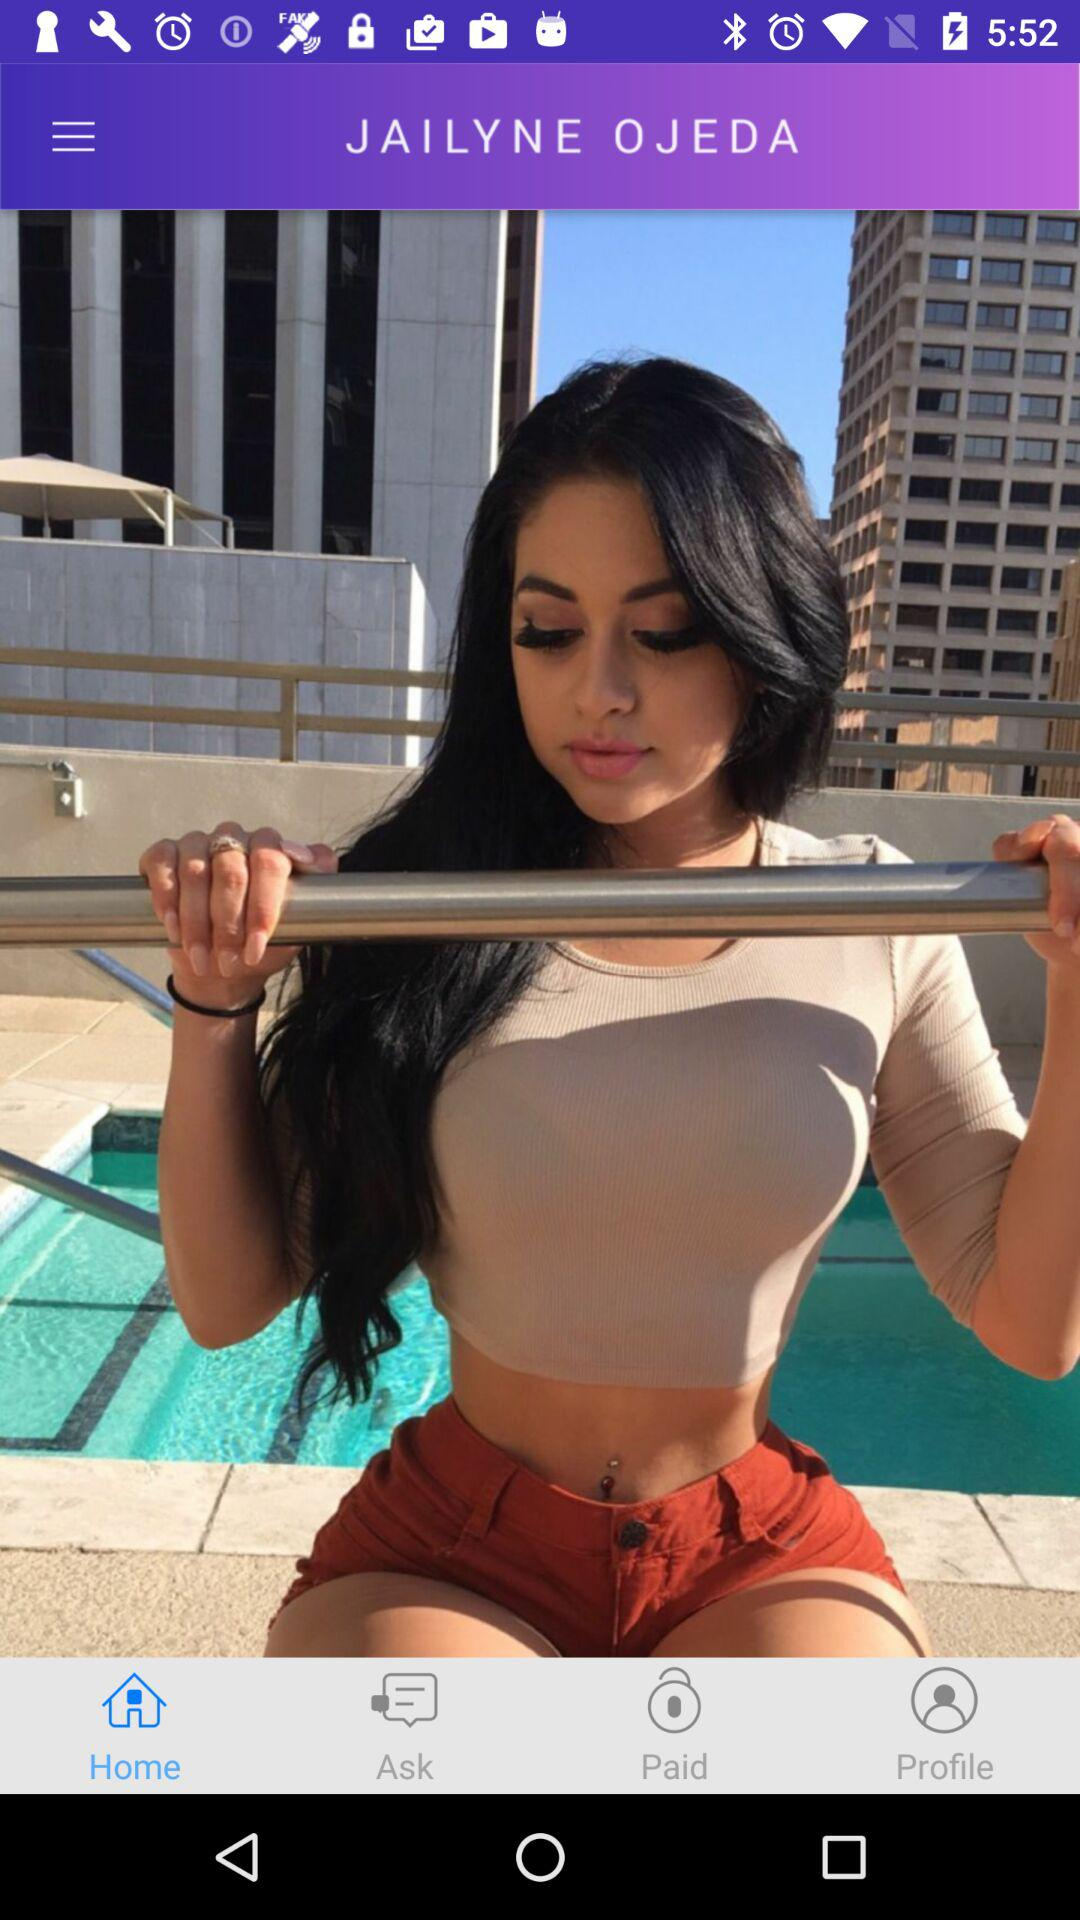What is the user's name? The user's name is Jailyne Ojeda. 